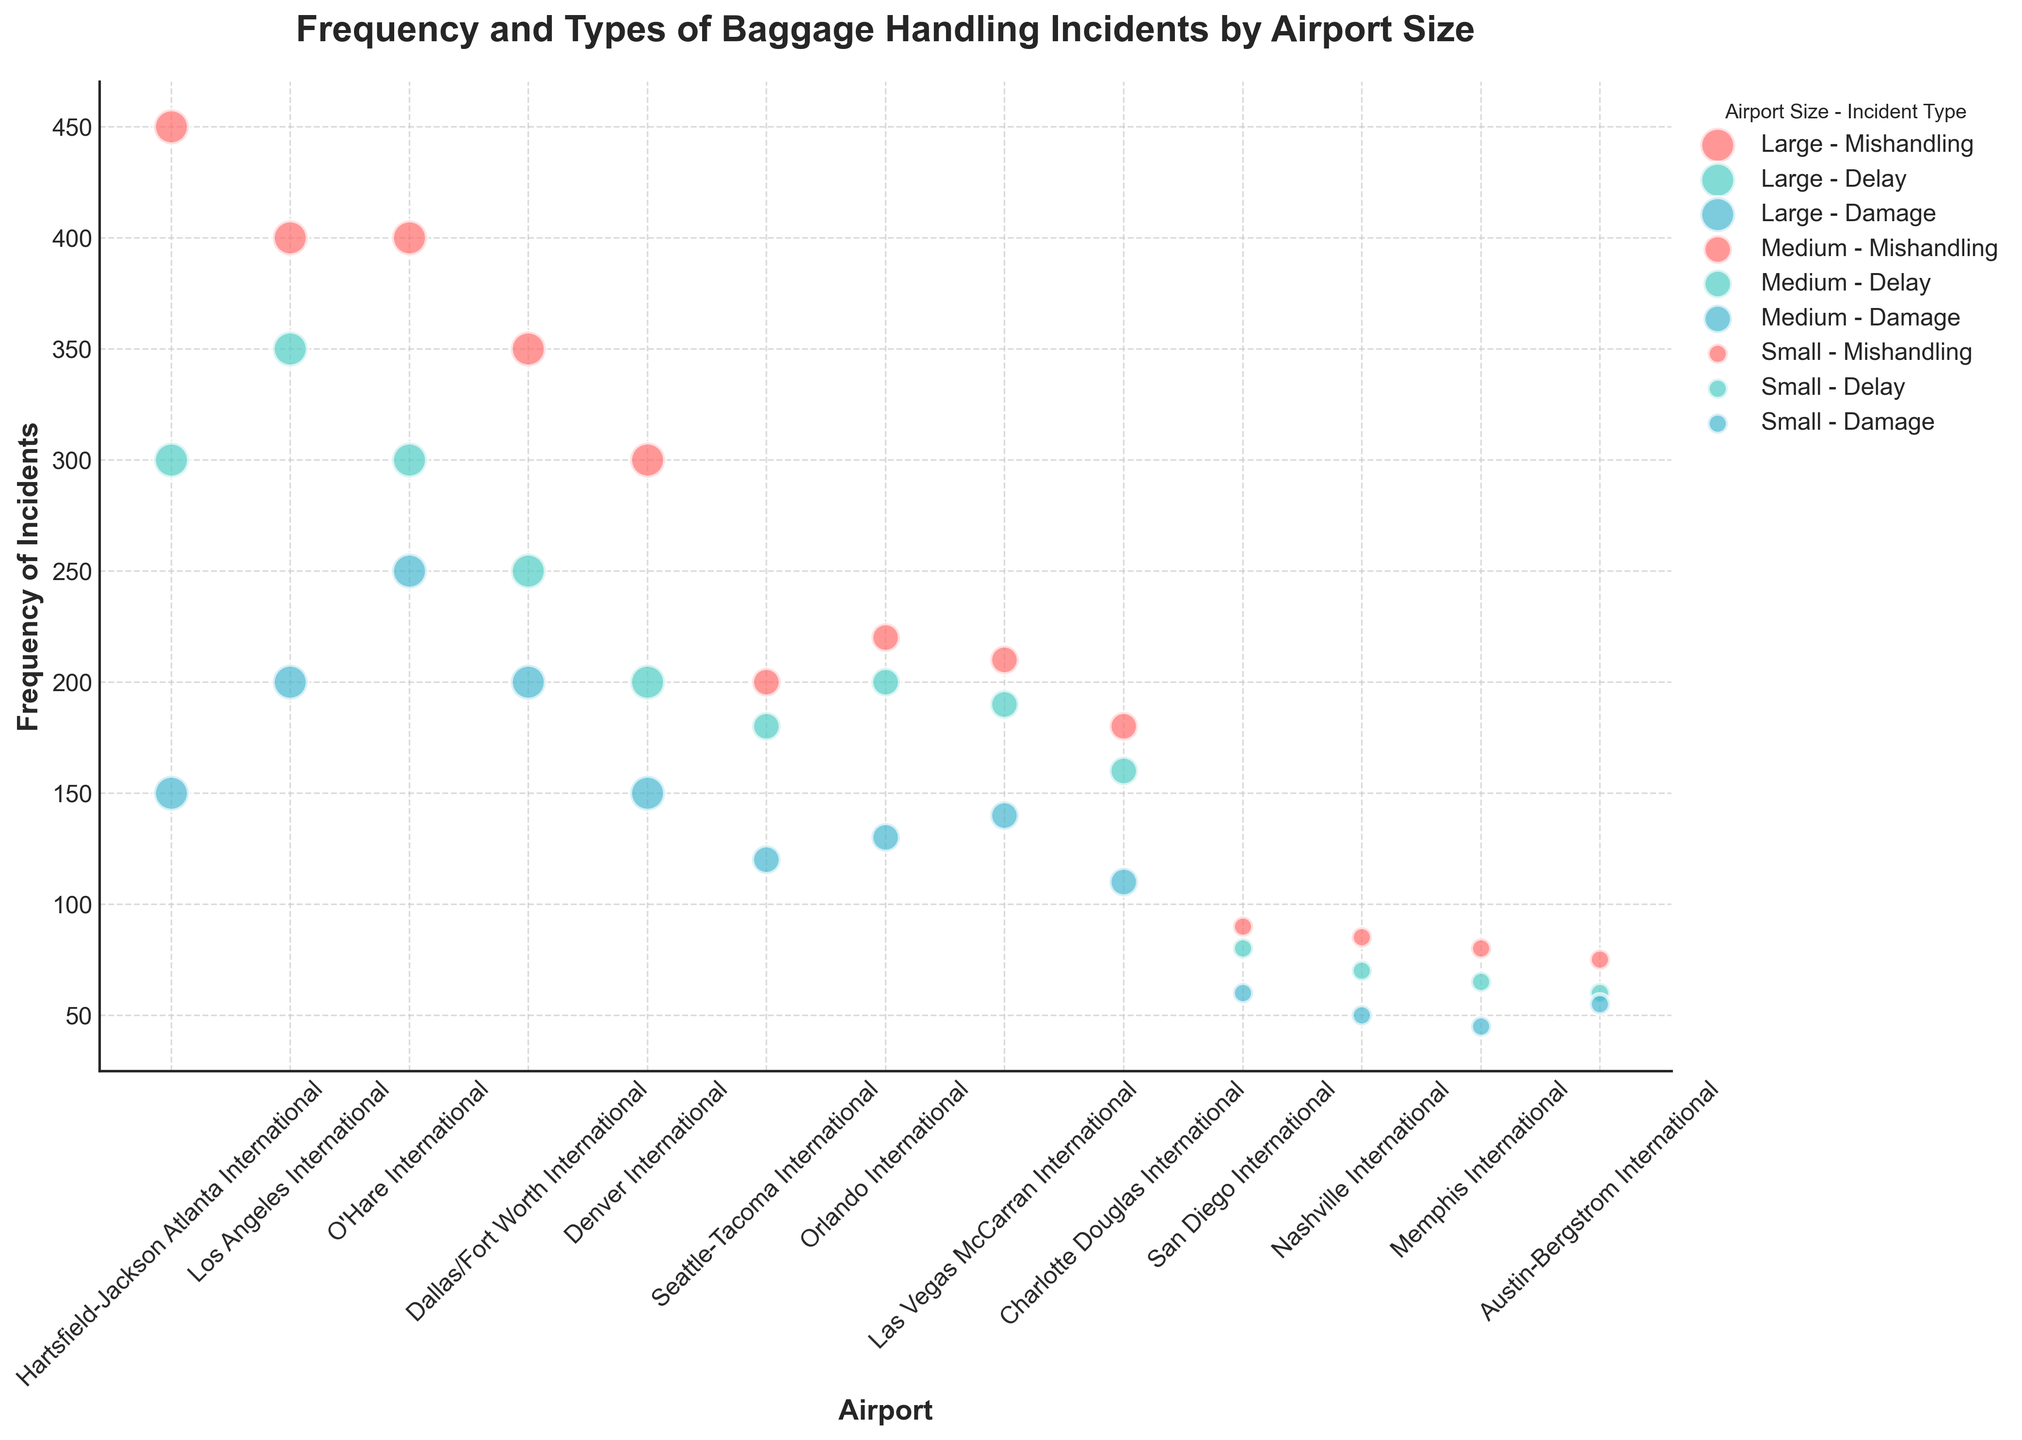What is the title of the figure? The title of the figure is prominently displayed at the top of the chart.
Answer: Frequency and Types of Baggage Handling Incidents by Airport Size Which airport has the highest frequency of delay incidents among large airports? Among large airports, the data points show that Los Angeles International has the highest frequency of delay incidents.
Answer: Los Angeles International What is the size and color coding for 'Damage' type incidents for medium airports? Medium airports have a size corresponding to a medium bubble size (200), and the color for 'Damage' incidents is represented by a shade of blue.
Answer: Medium size, blue color How does the frequency of mishandling incidents compare between Hartsfield-Jackson Atlanta International and Dallas/Fort Worth International? Hartsfield-Jackson Atlanta International has a frequency of 450 mishandling incidents, while Dallas/Fort Worth International has a frequency of 350 mishandling incidents. Therefore, Hartsfield-Jackson has more mishandling incidents compared to Dallas/Fort Worth.
Answer: Hartsfield-Jackson Atlanta International has more Which medium-sized airport has the fewest damage incidents? By examining medium-sized airports and their respective frequencies for damage incidents, Charlotte Douglas International, with 110 incidents, has the fewest.
Answer: Charlotte Douglas International What is the combined total frequency of delay incidents across all small airports? Summing the frequencies of delay incidents at small airports: San Diego International (80), Nashville International (70), Memphis International (65), and Austin-Bergstrom International (60), gives a total of 275.
Answer: 275 Compare the handling of delay and damage incidents at Seattle-Tacoma International. Which type has a higher frequency? At Seattle-Tacoma International, delay incidents have a frequency of 180, while damage incidents have a frequency of 120. Therefore, delay incidents have a higher frequency.
Answer: Delay incidents are higher How many total incidents are recorded for O'Hare International? Summing the incidents at O'Hare International: 400 mishandling, 300 delay, and 250 damage, gives a total of 950 incidents.
Answer: 950 Which incident type has the least occurrences at large airports? Rank them. Comparing all incident types at large airports: Damage incidents are the least frequent (150 at Hartsfield-Jackson, 200 at Los Angeles, 250 at O'Hare, 200 at Dallas/Fort Worth, and 150 at Denver). Therefore, damage incidents are the least frequent, followed by delay and mishandling.
Answer: Damage < Delay < Mishandling 